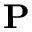Convert formula to latex. <formula><loc_0><loc_0><loc_500><loc_500>P</formula> 